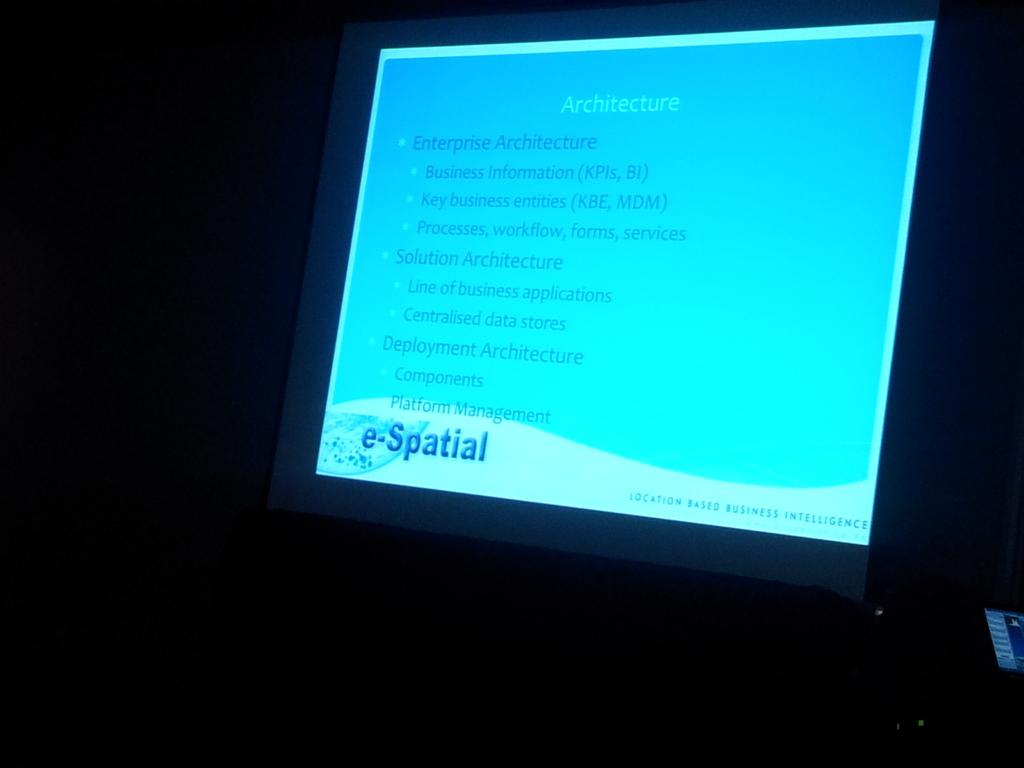<image>
Share a concise interpretation of the image provided. A monitor with the brand e-Spatial  on the front of it. 